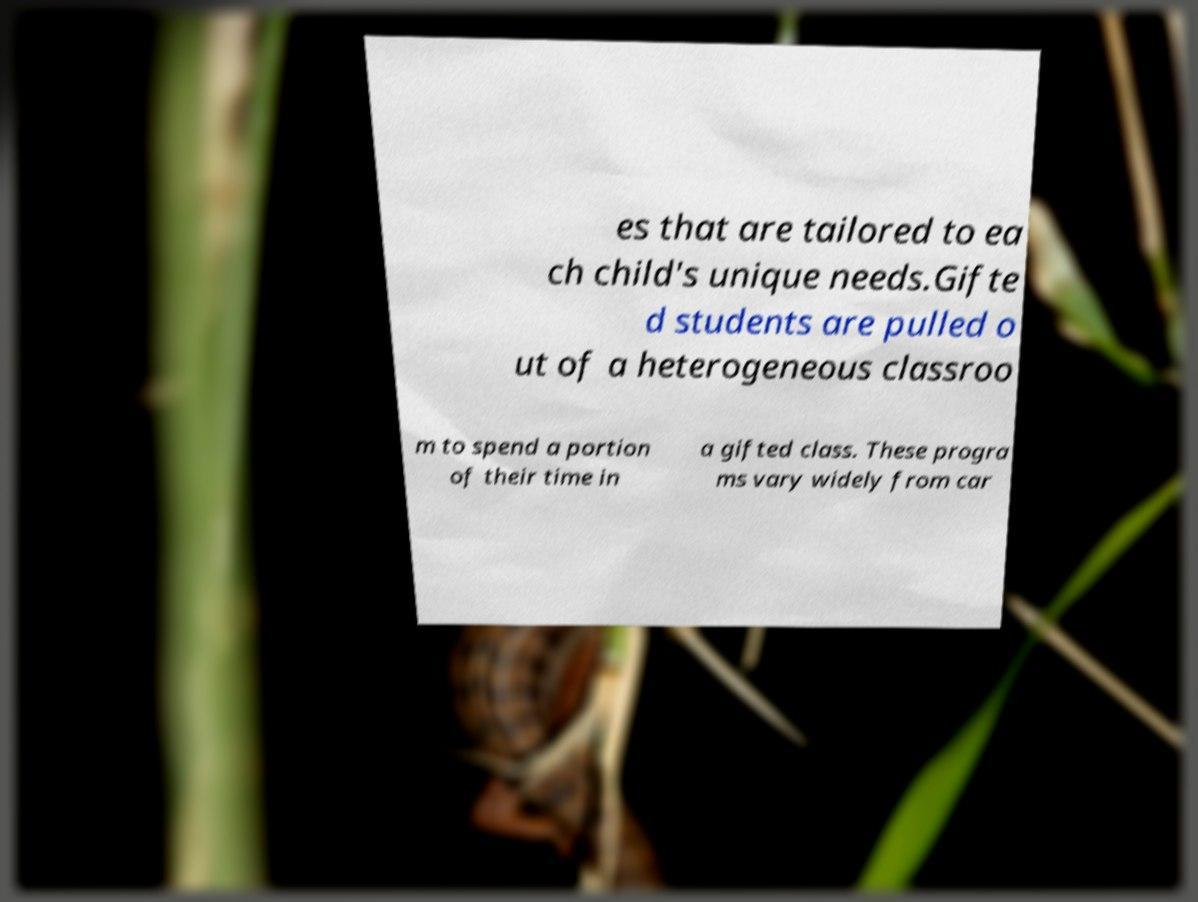What messages or text are displayed in this image? I need them in a readable, typed format. es that are tailored to ea ch child's unique needs.Gifte d students are pulled o ut of a heterogeneous classroo m to spend a portion of their time in a gifted class. These progra ms vary widely from car 